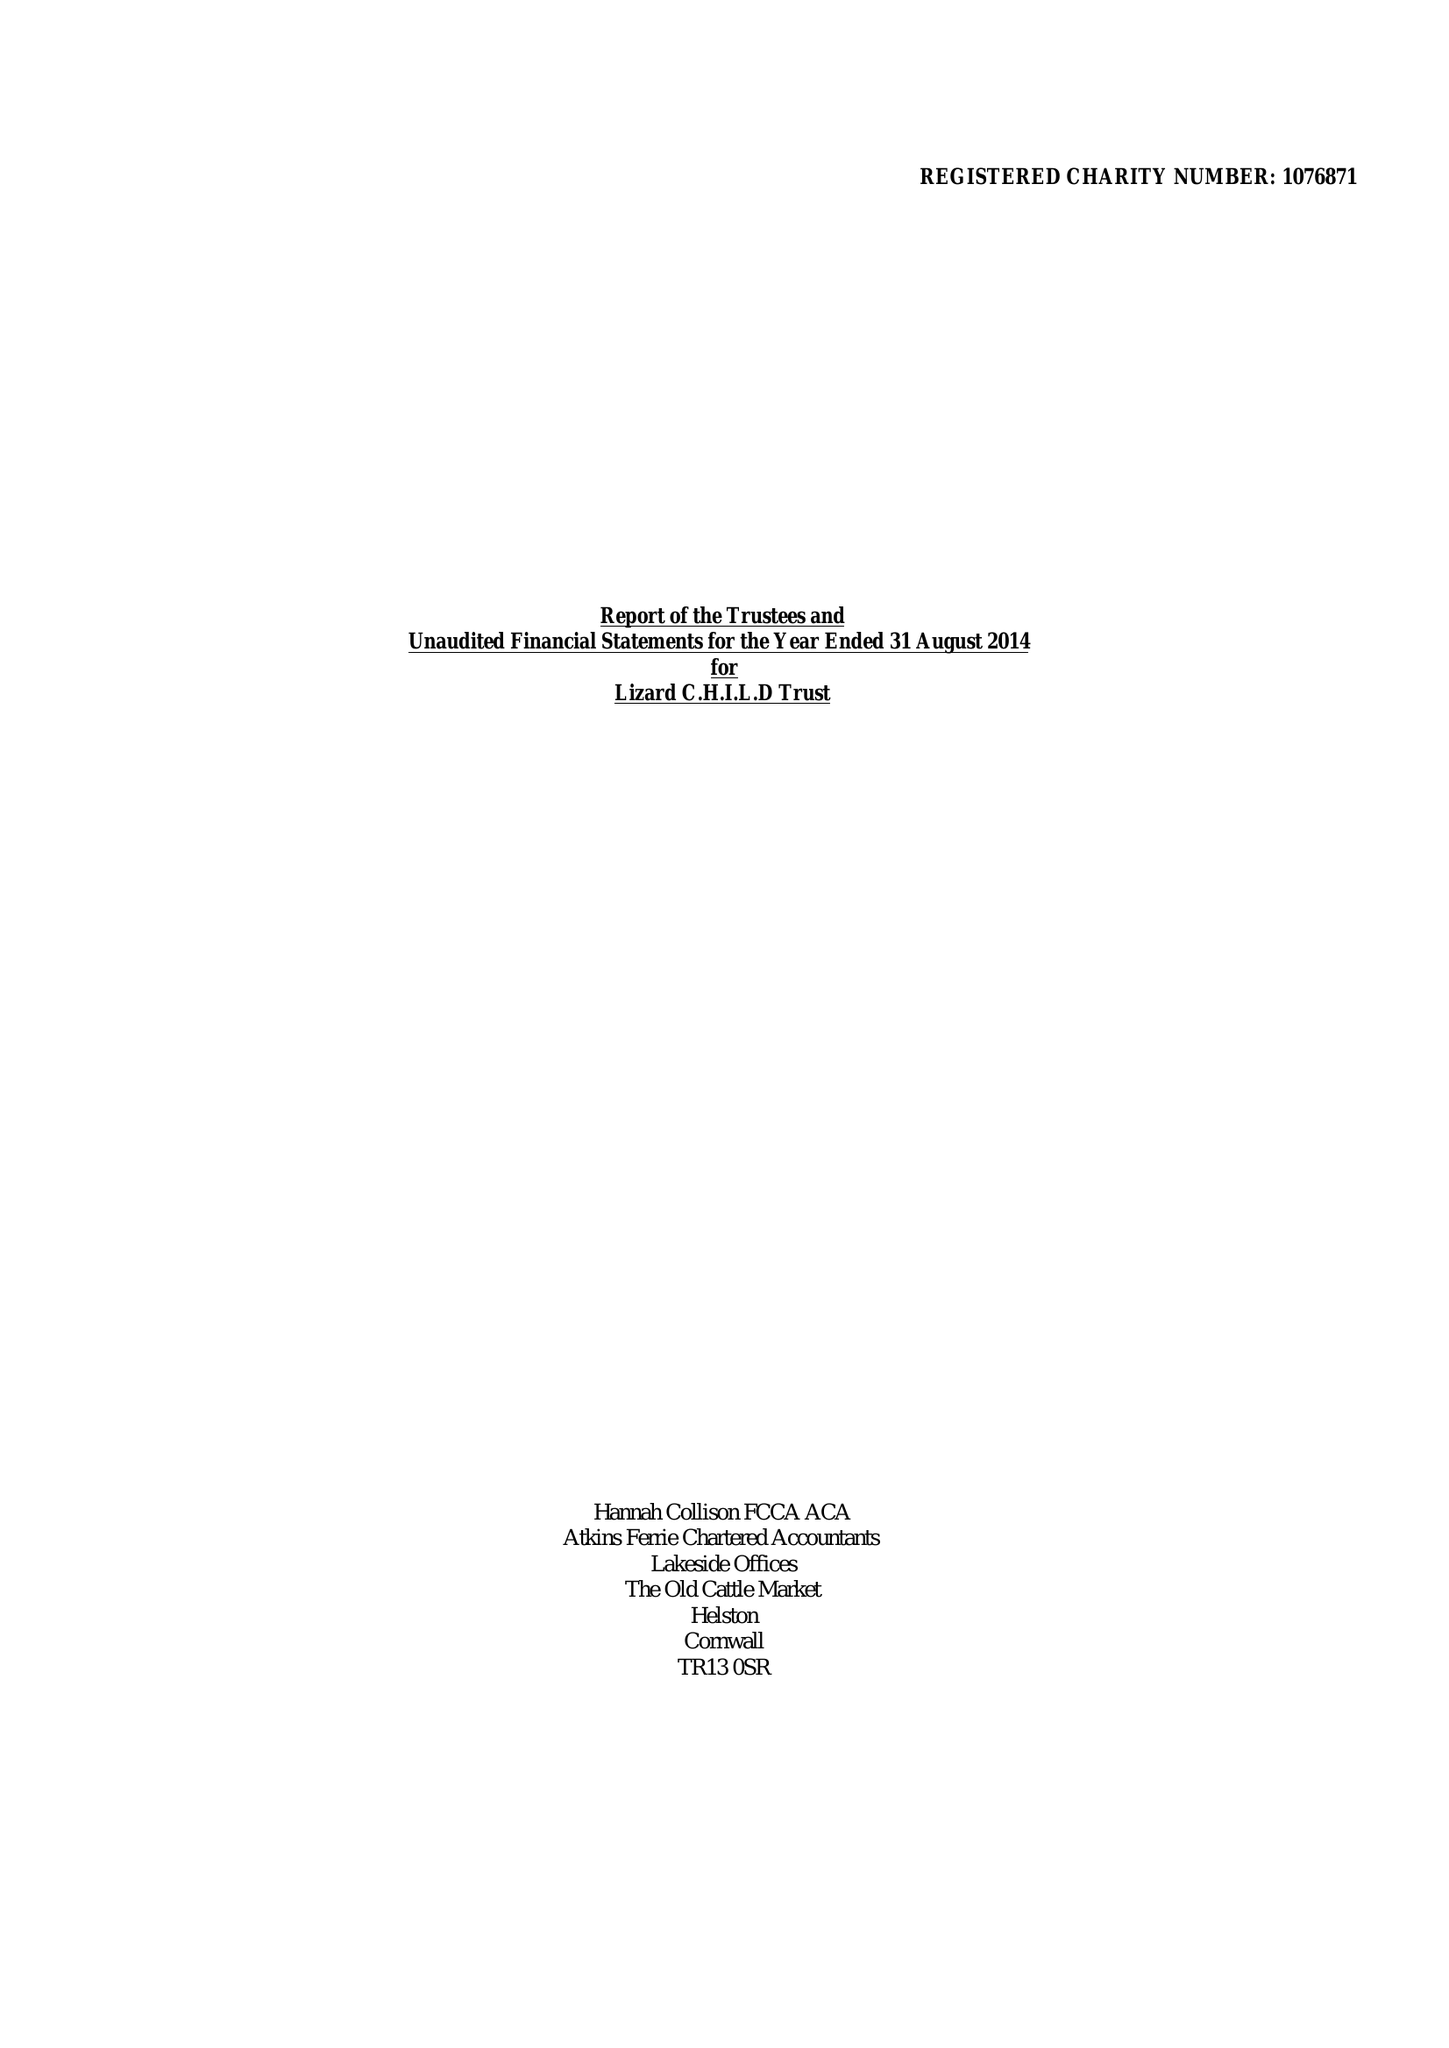What is the value for the charity_number?
Answer the question using a single word or phrase. 1076871 